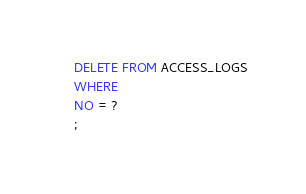<code> <loc_0><loc_0><loc_500><loc_500><_SQL_>DELETE FROM ACCESS_LOGS
WHERE 
NO = ?
;
</code> 